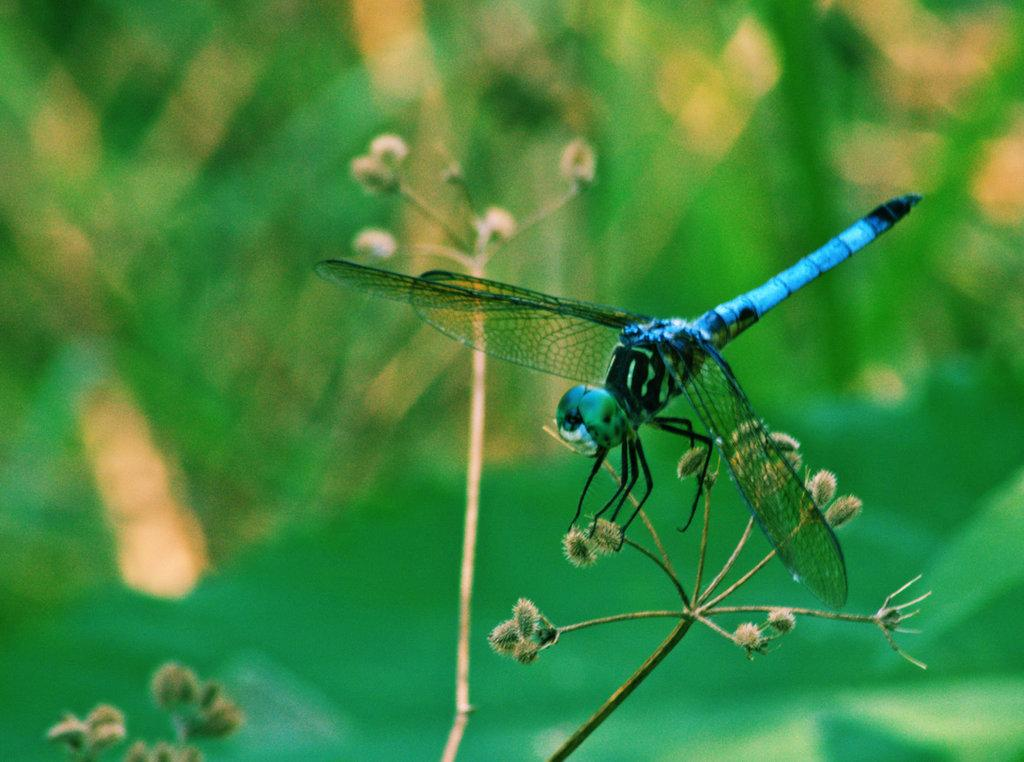What type of insect is present in the image? There is a dragonfly in the image. What other living organisms can be seen in the image? There are flowers in the image. What parts of the flowers are visible in the image? There are stems in the image. What colors are present in the background of the image? The background of the image is blue and green. Can you tell me how many geese are swimming in the tub in the image? There is no tub or geese present in the image. What type of musical instrument is being played by the dragonfly in the image? There is no musical instrument or dragonfly playing it in the image. 